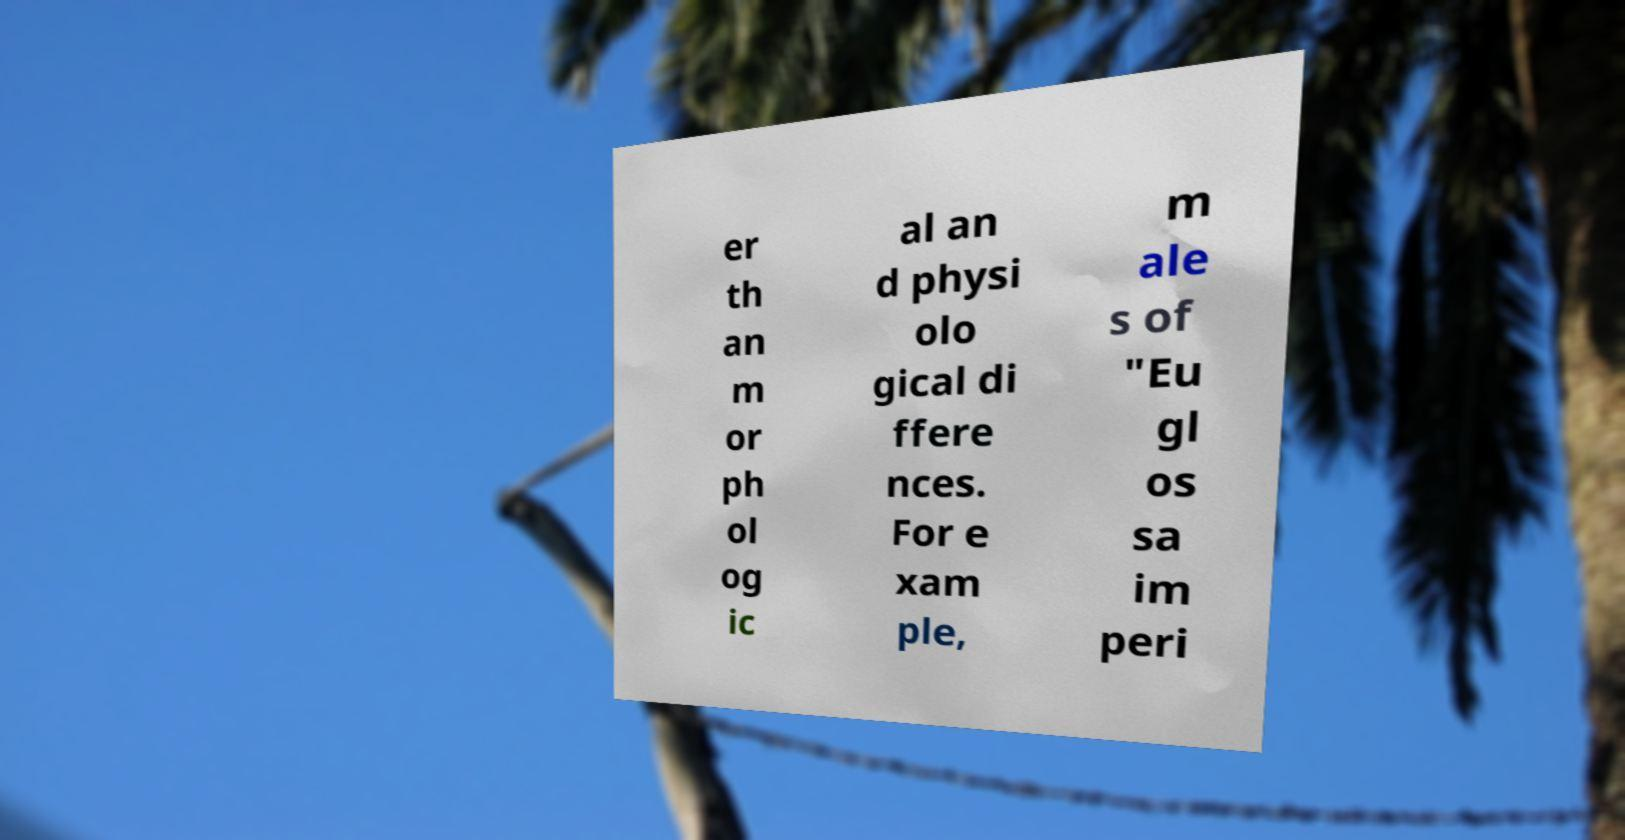Please read and relay the text visible in this image. What does it say? er th an m or ph ol og ic al an d physi olo gical di ffere nces. For e xam ple, m ale s of "Eu gl os sa im peri 